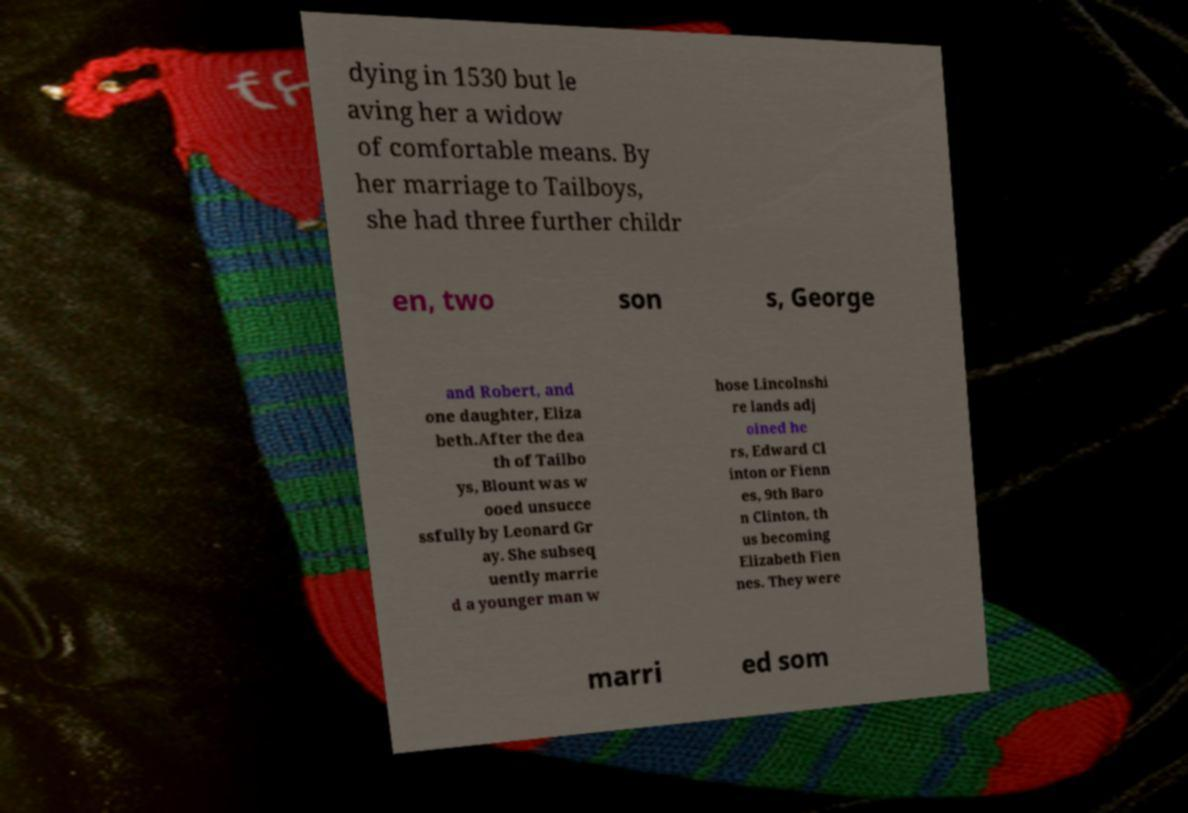Could you extract and type out the text from this image? dying in 1530 but le aving her a widow of comfortable means. By her marriage to Tailboys, she had three further childr en, two son s, George and Robert, and one daughter, Eliza beth.After the dea th of Tailbo ys, Blount was w ooed unsucce ssfully by Leonard Gr ay. She subseq uently marrie d a younger man w hose Lincolnshi re lands adj oined he rs, Edward Cl inton or Fienn es, 9th Baro n Clinton, th us becoming Elizabeth Fien nes. They were marri ed som 